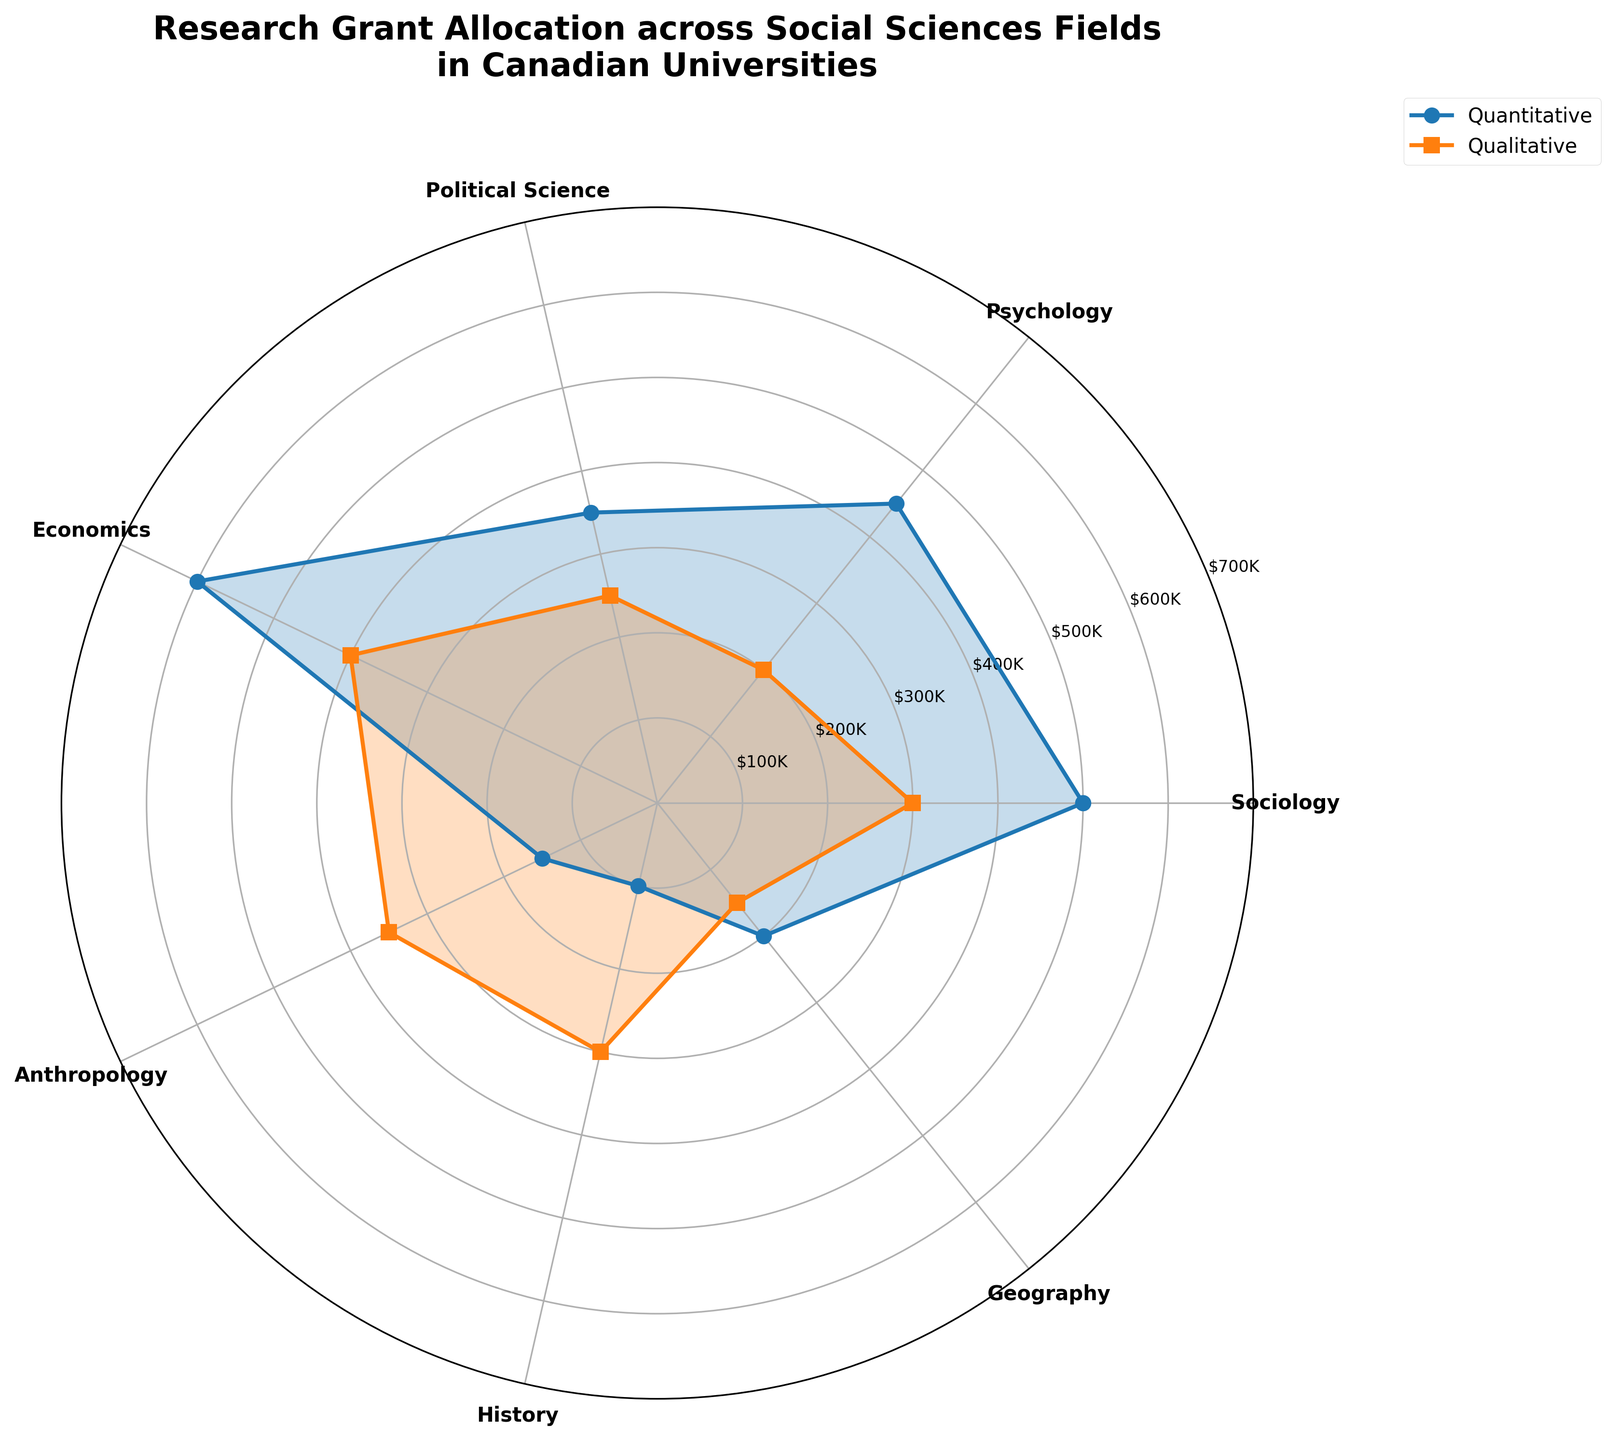What is the title of the plot? The title is typically found at the top of the figure. In this case, it should be clear and bold to signify the main topic of the visualization.
Answer: Research Grant Allocation across Social Sciences Fields in Canadian Universities How many fields are compared in this polar area chart? The number of fields corresponds to the distinct labels around the polar plot's circumference.
Answer: 7 Which field received the highest grant amount for quantitative research? Look at the data points labeled "Quantitative" and identify the one with the largest radial distance from the center.
Answer: Economics What is the total grant amount for Sociology across both types of research? Sum the quantitative and qualitative grant amounts for Sociology (500,000 + 300,000).
Answer: $800,000 What is the average grant amount for quantitative research across all fields? Sum all the quantitative grant amounts and divide by the number of fields (150,000 + 200,000 + 350,000 + 450,000 + 500,000 + 100,000 + 600,000) / 7.
Answer: $335,714 Is the grant amount for qualitative research higher in Anthropology or History? Compare the qualitative grant amounts for Anthropology and History (350,000 for Anthropology and 300,000 for History).
Answer: Anthropology What is the combined grant amount for Geography? Sum both the quantitative and qualitative grant amounts for Geography (200,000 + 150,000).
Answer: $350,000 Which type of research generally receives more funding across all fields? Compare the overall sum of quantitative and qualitative research grants across all fields. Quantitative: 150,000 + 200,000 + 350,000 + 450,000 + 500,000 + 100,000 + 600,000 = 2,350,000; Qualitative: 350,000 + 300,000 + 250,000 + 200,000 + 300,000 + 150,000 + 400,000 = 1,950,000. Quantitative has more funding.
Answer: Quantitative 